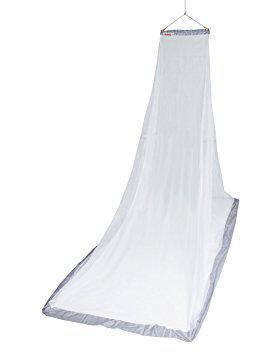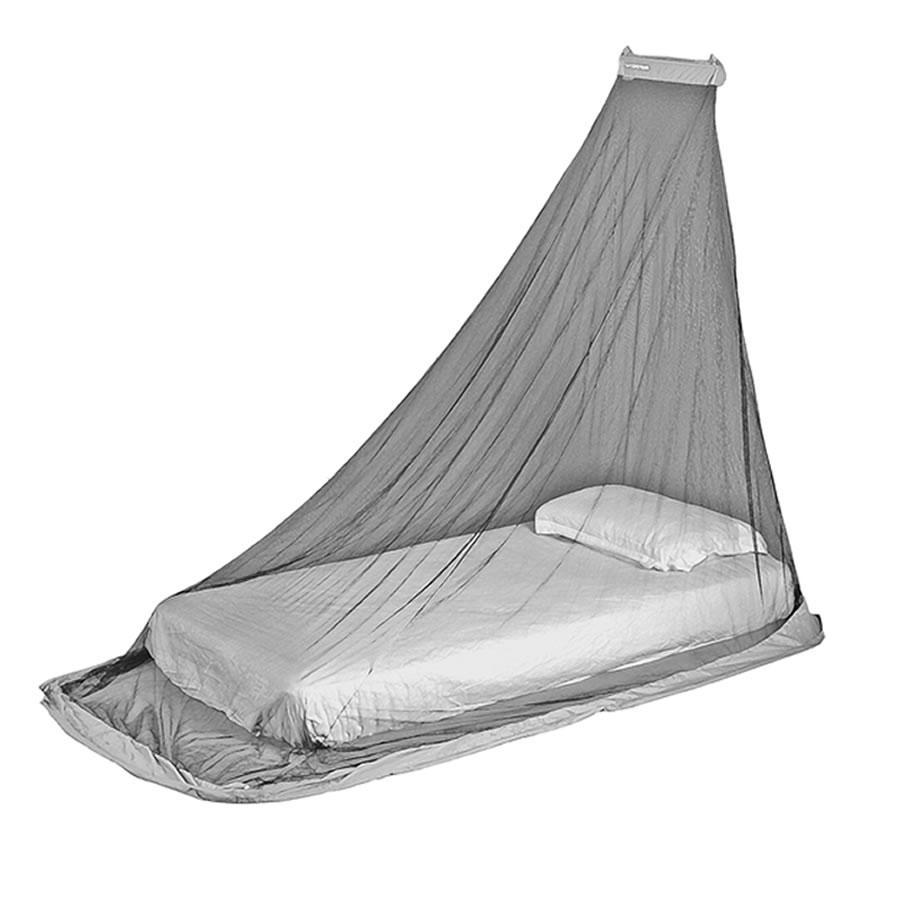The first image is the image on the left, the second image is the image on the right. Given the left and right images, does the statement "There is exactly one pillow on the bed in one of the images." hold true? Answer yes or no. Yes. 